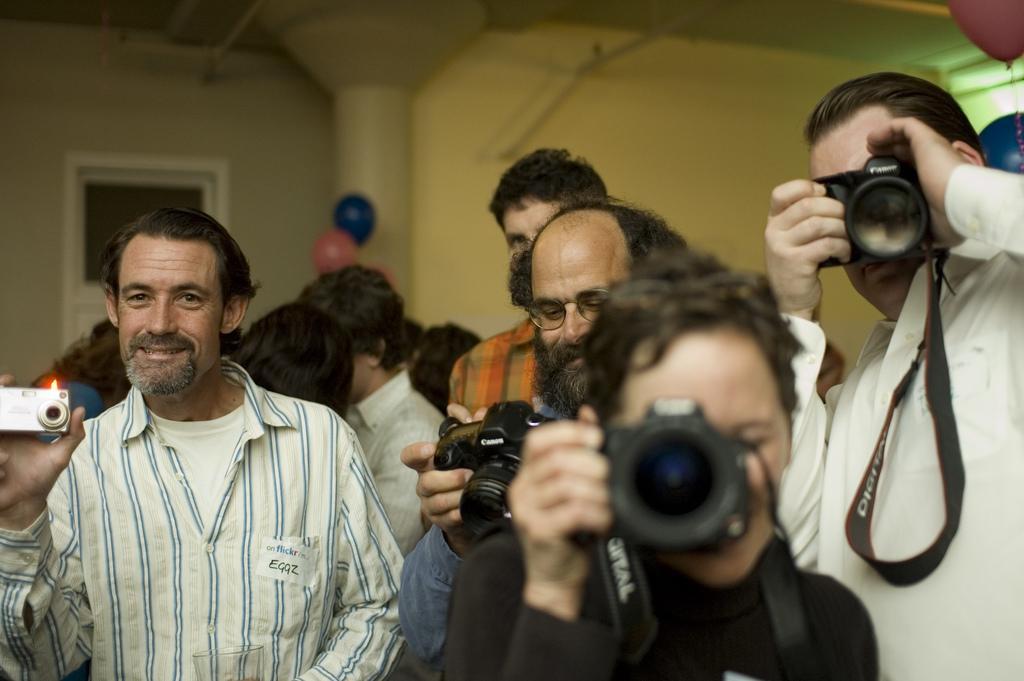How would you summarize this image in a sentence or two? In this picture we see many people standing. I think this picture is clicked inside the room. The man in the middle of the picture wearing black t-shirt is holding camera in his hands and clicking photos on camera. On the right corner of the picture, the man wearing white shirt is holding camera in his hands and he is also clicking photos in camera. Beside him, the man in blue shirt is holding camera in his hands. Behind them, we see a wall which is white in color and we even see pink and blue balloon. 